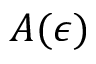<formula> <loc_0><loc_0><loc_500><loc_500>A ( \epsilon )</formula> 